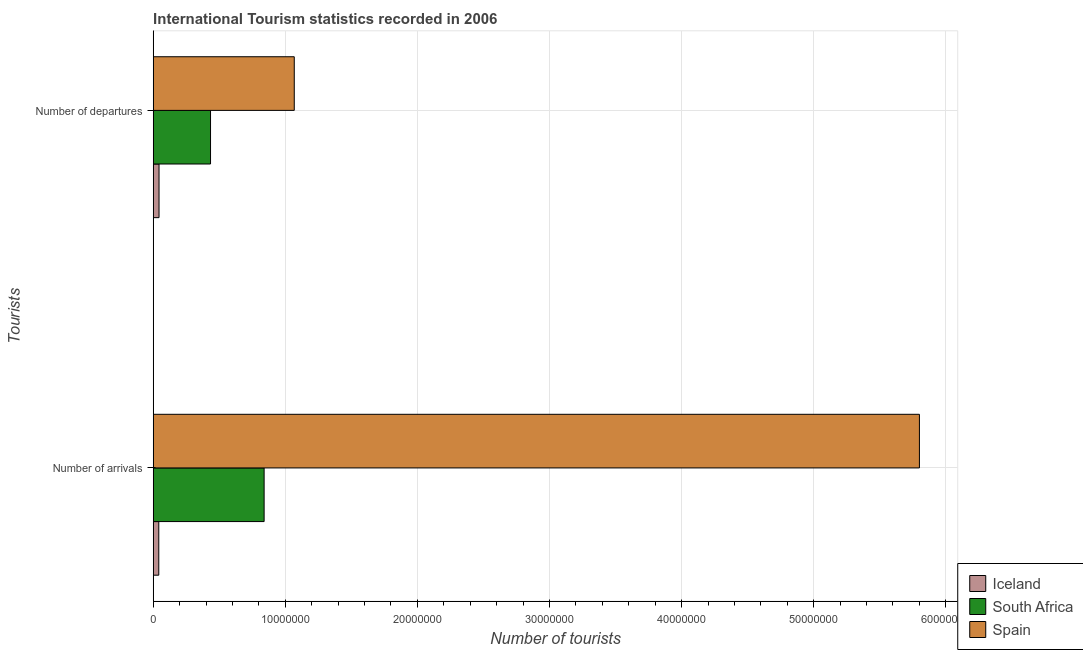How many different coloured bars are there?
Your answer should be compact. 3. How many groups of bars are there?
Your answer should be very brief. 2. Are the number of bars on each tick of the Y-axis equal?
Your answer should be very brief. Yes. What is the label of the 1st group of bars from the top?
Your answer should be very brief. Number of departures. What is the number of tourist arrivals in South Africa?
Keep it short and to the point. 8.40e+06. Across all countries, what is the maximum number of tourist arrivals?
Provide a short and direct response. 5.80e+07. Across all countries, what is the minimum number of tourist departures?
Offer a terse response. 4.40e+05. In which country was the number of tourist departures maximum?
Keep it short and to the point. Spain. What is the total number of tourist arrivals in the graph?
Provide a succinct answer. 6.68e+07. What is the difference between the number of tourist arrivals in Spain and that in Iceland?
Make the answer very short. 5.76e+07. What is the difference between the number of tourist arrivals in Iceland and the number of tourist departures in South Africa?
Keep it short and to the point. -3.92e+06. What is the average number of tourist arrivals per country?
Offer a very short reply. 2.23e+07. What is the difference between the number of tourist departures and number of tourist arrivals in South Africa?
Offer a terse response. -4.06e+06. In how many countries, is the number of tourist departures greater than 22000000 ?
Keep it short and to the point. 0. What is the ratio of the number of tourist arrivals in South Africa to that in Iceland?
Keep it short and to the point. 19.9. Is the number of tourist arrivals in Iceland less than that in Spain?
Keep it short and to the point. Yes. In how many countries, is the number of tourist arrivals greater than the average number of tourist arrivals taken over all countries?
Provide a succinct answer. 1. What does the 2nd bar from the top in Number of departures represents?
Ensure brevity in your answer.  South Africa. Are all the bars in the graph horizontal?
Ensure brevity in your answer.  Yes. What is the difference between two consecutive major ticks on the X-axis?
Provide a succinct answer. 1.00e+07. Are the values on the major ticks of X-axis written in scientific E-notation?
Offer a terse response. No. Does the graph contain any zero values?
Your answer should be very brief. No. Does the graph contain grids?
Ensure brevity in your answer.  Yes. How many legend labels are there?
Keep it short and to the point. 3. What is the title of the graph?
Your response must be concise. International Tourism statistics recorded in 2006. Does "High income" appear as one of the legend labels in the graph?
Keep it short and to the point. No. What is the label or title of the X-axis?
Give a very brief answer. Number of tourists. What is the label or title of the Y-axis?
Keep it short and to the point. Tourists. What is the Number of tourists in Iceland in Number of arrivals?
Give a very brief answer. 4.22e+05. What is the Number of tourists of South Africa in Number of arrivals?
Provide a succinct answer. 8.40e+06. What is the Number of tourists in Spain in Number of arrivals?
Provide a short and direct response. 5.80e+07. What is the Number of tourists in South Africa in Number of departures?
Your answer should be very brief. 4.34e+06. What is the Number of tourists of Spain in Number of departures?
Your answer should be compact. 1.07e+07. Across all Tourists, what is the maximum Number of tourists in Iceland?
Your answer should be very brief. 4.40e+05. Across all Tourists, what is the maximum Number of tourists of South Africa?
Ensure brevity in your answer.  8.40e+06. Across all Tourists, what is the maximum Number of tourists of Spain?
Give a very brief answer. 5.80e+07. Across all Tourists, what is the minimum Number of tourists in Iceland?
Your answer should be very brief. 4.22e+05. Across all Tourists, what is the minimum Number of tourists in South Africa?
Offer a terse response. 4.34e+06. Across all Tourists, what is the minimum Number of tourists of Spain?
Provide a short and direct response. 1.07e+07. What is the total Number of tourists in Iceland in the graph?
Make the answer very short. 8.62e+05. What is the total Number of tourists in South Africa in the graph?
Offer a terse response. 1.27e+07. What is the total Number of tourists in Spain in the graph?
Offer a very short reply. 6.87e+07. What is the difference between the Number of tourists of Iceland in Number of arrivals and that in Number of departures?
Your answer should be compact. -1.80e+04. What is the difference between the Number of tourists of South Africa in Number of arrivals and that in Number of departures?
Offer a very short reply. 4.06e+06. What is the difference between the Number of tourists of Spain in Number of arrivals and that in Number of departures?
Your answer should be compact. 4.73e+07. What is the difference between the Number of tourists of Iceland in Number of arrivals and the Number of tourists of South Africa in Number of departures?
Make the answer very short. -3.92e+06. What is the difference between the Number of tourists of Iceland in Number of arrivals and the Number of tourists of Spain in Number of departures?
Your response must be concise. -1.03e+07. What is the difference between the Number of tourists in South Africa in Number of arrivals and the Number of tourists in Spain in Number of departures?
Keep it short and to the point. -2.28e+06. What is the average Number of tourists in Iceland per Tourists?
Offer a very short reply. 4.31e+05. What is the average Number of tourists of South Africa per Tourists?
Ensure brevity in your answer.  6.37e+06. What is the average Number of tourists in Spain per Tourists?
Offer a very short reply. 3.43e+07. What is the difference between the Number of tourists of Iceland and Number of tourists of South Africa in Number of arrivals?
Ensure brevity in your answer.  -7.97e+06. What is the difference between the Number of tourists in Iceland and Number of tourists in Spain in Number of arrivals?
Offer a very short reply. -5.76e+07. What is the difference between the Number of tourists of South Africa and Number of tourists of Spain in Number of arrivals?
Provide a short and direct response. -4.96e+07. What is the difference between the Number of tourists in Iceland and Number of tourists in South Africa in Number of departures?
Offer a very short reply. -3.90e+06. What is the difference between the Number of tourists in Iceland and Number of tourists in Spain in Number of departures?
Offer a terse response. -1.02e+07. What is the difference between the Number of tourists in South Africa and Number of tourists in Spain in Number of departures?
Your response must be concise. -6.34e+06. What is the ratio of the Number of tourists in Iceland in Number of arrivals to that in Number of departures?
Keep it short and to the point. 0.96. What is the ratio of the Number of tourists in South Africa in Number of arrivals to that in Number of departures?
Give a very brief answer. 1.94. What is the ratio of the Number of tourists in Spain in Number of arrivals to that in Number of departures?
Ensure brevity in your answer.  5.43. What is the difference between the highest and the second highest Number of tourists of Iceland?
Provide a short and direct response. 1.80e+04. What is the difference between the highest and the second highest Number of tourists in South Africa?
Provide a succinct answer. 4.06e+06. What is the difference between the highest and the second highest Number of tourists in Spain?
Give a very brief answer. 4.73e+07. What is the difference between the highest and the lowest Number of tourists of Iceland?
Your response must be concise. 1.80e+04. What is the difference between the highest and the lowest Number of tourists in South Africa?
Offer a terse response. 4.06e+06. What is the difference between the highest and the lowest Number of tourists in Spain?
Keep it short and to the point. 4.73e+07. 